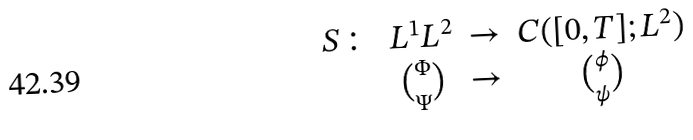<formula> <loc_0><loc_0><loc_500><loc_500>\begin{array} { c c c c } S \colon & L ^ { 1 } L ^ { 2 } & \to & C ( [ 0 , T ] ; L ^ { 2 } ) \\ & { \Phi \choose \Psi } & \to & { \phi \choose \psi } \end{array}</formula> 